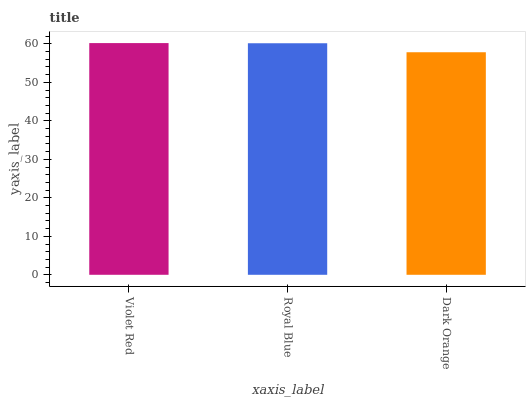Is Dark Orange the minimum?
Answer yes or no. Yes. Is Violet Red the maximum?
Answer yes or no. Yes. Is Royal Blue the minimum?
Answer yes or no. No. Is Royal Blue the maximum?
Answer yes or no. No. Is Violet Red greater than Royal Blue?
Answer yes or no. Yes. Is Royal Blue less than Violet Red?
Answer yes or no. Yes. Is Royal Blue greater than Violet Red?
Answer yes or no. No. Is Violet Red less than Royal Blue?
Answer yes or no. No. Is Royal Blue the high median?
Answer yes or no. Yes. Is Royal Blue the low median?
Answer yes or no. Yes. Is Dark Orange the high median?
Answer yes or no. No. Is Violet Red the low median?
Answer yes or no. No. 